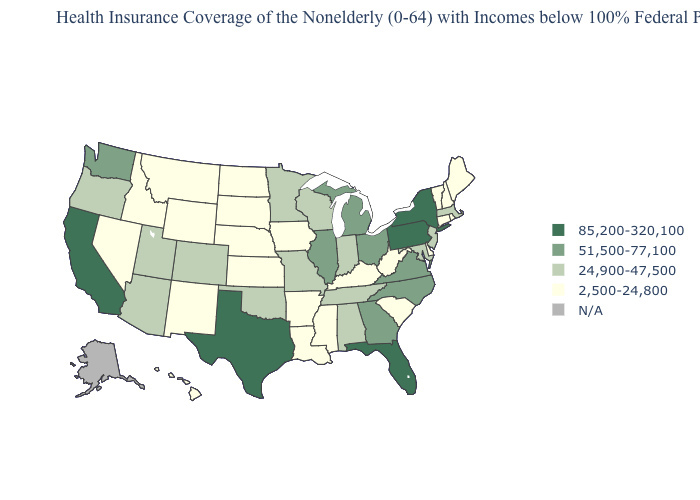What is the lowest value in the USA?
Quick response, please. 2,500-24,800. Does Michigan have the lowest value in the USA?
Answer briefly. No. How many symbols are there in the legend?
Write a very short answer. 5. Does Vermont have the highest value in the Northeast?
Be succinct. No. Name the states that have a value in the range 85,200-320,100?
Quick response, please. California, Florida, New York, Pennsylvania, Texas. Name the states that have a value in the range 51,500-77,100?
Be succinct. Georgia, Illinois, Michigan, North Carolina, Ohio, Virginia, Washington. Among the states that border West Virginia , does Ohio have the highest value?
Write a very short answer. No. Does Nevada have the highest value in the West?
Short answer required. No. Name the states that have a value in the range 51,500-77,100?
Keep it brief. Georgia, Illinois, Michigan, North Carolina, Ohio, Virginia, Washington. What is the highest value in the West ?
Be succinct. 85,200-320,100. Name the states that have a value in the range 2,500-24,800?
Answer briefly. Arkansas, Connecticut, Delaware, Hawaii, Idaho, Iowa, Kansas, Kentucky, Louisiana, Maine, Mississippi, Montana, Nebraska, Nevada, New Hampshire, New Mexico, North Dakota, Rhode Island, South Carolina, South Dakota, Vermont, West Virginia, Wyoming. What is the lowest value in the USA?
Keep it brief. 2,500-24,800. Is the legend a continuous bar?
Keep it brief. No. Which states have the lowest value in the USA?
Keep it brief. Arkansas, Connecticut, Delaware, Hawaii, Idaho, Iowa, Kansas, Kentucky, Louisiana, Maine, Mississippi, Montana, Nebraska, Nevada, New Hampshire, New Mexico, North Dakota, Rhode Island, South Carolina, South Dakota, Vermont, West Virginia, Wyoming. 